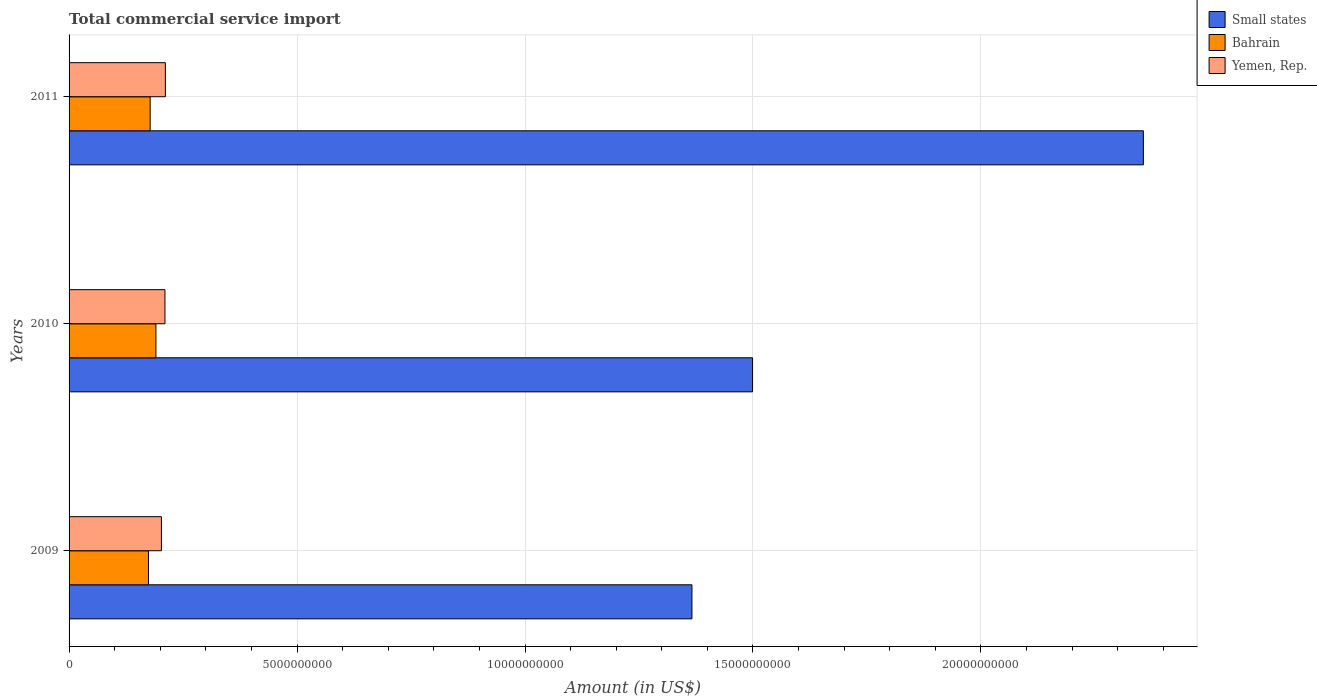How many groups of bars are there?
Provide a succinct answer. 3. How many bars are there on the 3rd tick from the bottom?
Make the answer very short. 3. What is the label of the 1st group of bars from the top?
Provide a short and direct response. 2011. In how many cases, is the number of bars for a given year not equal to the number of legend labels?
Keep it short and to the point. 0. What is the total commercial service import in Bahrain in 2011?
Ensure brevity in your answer.  1.78e+09. Across all years, what is the maximum total commercial service import in Bahrain?
Offer a terse response. 1.91e+09. Across all years, what is the minimum total commercial service import in Bahrain?
Keep it short and to the point. 1.74e+09. In which year was the total commercial service import in Small states minimum?
Your response must be concise. 2009. What is the total total commercial service import in Bahrain in the graph?
Keep it short and to the point. 5.42e+09. What is the difference between the total commercial service import in Bahrain in 2010 and that in 2011?
Offer a very short reply. 1.27e+08. What is the difference between the total commercial service import in Bahrain in 2009 and the total commercial service import in Small states in 2011?
Ensure brevity in your answer.  -2.18e+1. What is the average total commercial service import in Bahrain per year?
Offer a terse response. 1.81e+09. In the year 2010, what is the difference between the total commercial service import in Bahrain and total commercial service import in Small states?
Give a very brief answer. -1.31e+1. In how many years, is the total commercial service import in Bahrain greater than 3000000000 US$?
Ensure brevity in your answer.  0. What is the ratio of the total commercial service import in Bahrain in 2009 to that in 2011?
Offer a terse response. 0.98. Is the total commercial service import in Bahrain in 2009 less than that in 2011?
Your answer should be compact. Yes. What is the difference between the highest and the second highest total commercial service import in Yemen, Rep.?
Ensure brevity in your answer.  9.16e+06. What is the difference between the highest and the lowest total commercial service import in Bahrain?
Make the answer very short. 1.64e+08. Is the sum of the total commercial service import in Yemen, Rep. in 2009 and 2010 greater than the maximum total commercial service import in Bahrain across all years?
Make the answer very short. Yes. What does the 1st bar from the top in 2009 represents?
Offer a terse response. Yemen, Rep. What does the 1st bar from the bottom in 2011 represents?
Offer a terse response. Small states. Is it the case that in every year, the sum of the total commercial service import in Yemen, Rep. and total commercial service import in Bahrain is greater than the total commercial service import in Small states?
Your answer should be very brief. No. How many bars are there?
Your answer should be compact. 9. How many years are there in the graph?
Make the answer very short. 3. Are the values on the major ticks of X-axis written in scientific E-notation?
Ensure brevity in your answer.  No. Does the graph contain any zero values?
Offer a very short reply. No. Does the graph contain grids?
Keep it short and to the point. Yes. How many legend labels are there?
Make the answer very short. 3. How are the legend labels stacked?
Your answer should be very brief. Vertical. What is the title of the graph?
Offer a very short reply. Total commercial service import. Does "Cameroon" appear as one of the legend labels in the graph?
Ensure brevity in your answer.  No. What is the label or title of the X-axis?
Keep it short and to the point. Amount (in US$). What is the label or title of the Y-axis?
Give a very brief answer. Years. What is the Amount (in US$) of Small states in 2009?
Provide a succinct answer. 1.37e+1. What is the Amount (in US$) of Bahrain in 2009?
Ensure brevity in your answer.  1.74e+09. What is the Amount (in US$) in Yemen, Rep. in 2009?
Make the answer very short. 2.03e+09. What is the Amount (in US$) of Small states in 2010?
Ensure brevity in your answer.  1.50e+1. What is the Amount (in US$) of Bahrain in 2010?
Your answer should be compact. 1.91e+09. What is the Amount (in US$) in Yemen, Rep. in 2010?
Provide a succinct answer. 2.10e+09. What is the Amount (in US$) in Small states in 2011?
Provide a succinct answer. 2.36e+1. What is the Amount (in US$) in Bahrain in 2011?
Offer a very short reply. 1.78e+09. What is the Amount (in US$) of Yemen, Rep. in 2011?
Provide a succinct answer. 2.11e+09. Across all years, what is the maximum Amount (in US$) in Small states?
Ensure brevity in your answer.  2.36e+1. Across all years, what is the maximum Amount (in US$) of Bahrain?
Offer a terse response. 1.91e+09. Across all years, what is the maximum Amount (in US$) in Yemen, Rep.?
Your response must be concise. 2.11e+09. Across all years, what is the minimum Amount (in US$) in Small states?
Provide a succinct answer. 1.37e+1. Across all years, what is the minimum Amount (in US$) in Bahrain?
Your answer should be compact. 1.74e+09. Across all years, what is the minimum Amount (in US$) of Yemen, Rep.?
Your answer should be compact. 2.03e+09. What is the total Amount (in US$) of Small states in the graph?
Your answer should be very brief. 5.22e+1. What is the total Amount (in US$) of Bahrain in the graph?
Your answer should be compact. 5.42e+09. What is the total Amount (in US$) in Yemen, Rep. in the graph?
Make the answer very short. 6.24e+09. What is the difference between the Amount (in US$) in Small states in 2009 and that in 2010?
Provide a short and direct response. -1.33e+09. What is the difference between the Amount (in US$) of Bahrain in 2009 and that in 2010?
Give a very brief answer. -1.64e+08. What is the difference between the Amount (in US$) of Yemen, Rep. in 2009 and that in 2010?
Give a very brief answer. -7.75e+07. What is the difference between the Amount (in US$) of Small states in 2009 and that in 2011?
Keep it short and to the point. -9.90e+09. What is the difference between the Amount (in US$) of Bahrain in 2009 and that in 2011?
Your answer should be very brief. -3.75e+07. What is the difference between the Amount (in US$) in Yemen, Rep. in 2009 and that in 2011?
Ensure brevity in your answer.  -8.66e+07. What is the difference between the Amount (in US$) of Small states in 2010 and that in 2011?
Provide a short and direct response. -8.57e+09. What is the difference between the Amount (in US$) in Bahrain in 2010 and that in 2011?
Your answer should be compact. 1.27e+08. What is the difference between the Amount (in US$) in Yemen, Rep. in 2010 and that in 2011?
Your answer should be compact. -9.16e+06. What is the difference between the Amount (in US$) in Small states in 2009 and the Amount (in US$) in Bahrain in 2010?
Keep it short and to the point. 1.18e+1. What is the difference between the Amount (in US$) in Small states in 2009 and the Amount (in US$) in Yemen, Rep. in 2010?
Offer a very short reply. 1.16e+1. What is the difference between the Amount (in US$) in Bahrain in 2009 and the Amount (in US$) in Yemen, Rep. in 2010?
Give a very brief answer. -3.62e+08. What is the difference between the Amount (in US$) in Small states in 2009 and the Amount (in US$) in Bahrain in 2011?
Your answer should be very brief. 1.19e+1. What is the difference between the Amount (in US$) of Small states in 2009 and the Amount (in US$) of Yemen, Rep. in 2011?
Offer a terse response. 1.15e+1. What is the difference between the Amount (in US$) of Bahrain in 2009 and the Amount (in US$) of Yemen, Rep. in 2011?
Your response must be concise. -3.71e+08. What is the difference between the Amount (in US$) of Small states in 2010 and the Amount (in US$) of Bahrain in 2011?
Give a very brief answer. 1.32e+1. What is the difference between the Amount (in US$) in Small states in 2010 and the Amount (in US$) in Yemen, Rep. in 2011?
Give a very brief answer. 1.29e+1. What is the difference between the Amount (in US$) of Bahrain in 2010 and the Amount (in US$) of Yemen, Rep. in 2011?
Offer a terse response. -2.07e+08. What is the average Amount (in US$) of Small states per year?
Your response must be concise. 1.74e+1. What is the average Amount (in US$) of Bahrain per year?
Offer a very short reply. 1.81e+09. What is the average Amount (in US$) in Yemen, Rep. per year?
Make the answer very short. 2.08e+09. In the year 2009, what is the difference between the Amount (in US$) in Small states and Amount (in US$) in Bahrain?
Provide a short and direct response. 1.19e+1. In the year 2009, what is the difference between the Amount (in US$) in Small states and Amount (in US$) in Yemen, Rep.?
Offer a very short reply. 1.16e+1. In the year 2009, what is the difference between the Amount (in US$) of Bahrain and Amount (in US$) of Yemen, Rep.?
Offer a terse response. -2.84e+08. In the year 2010, what is the difference between the Amount (in US$) of Small states and Amount (in US$) of Bahrain?
Keep it short and to the point. 1.31e+1. In the year 2010, what is the difference between the Amount (in US$) in Small states and Amount (in US$) in Yemen, Rep.?
Keep it short and to the point. 1.29e+1. In the year 2010, what is the difference between the Amount (in US$) in Bahrain and Amount (in US$) in Yemen, Rep.?
Keep it short and to the point. -1.98e+08. In the year 2011, what is the difference between the Amount (in US$) in Small states and Amount (in US$) in Bahrain?
Keep it short and to the point. 2.18e+1. In the year 2011, what is the difference between the Amount (in US$) in Small states and Amount (in US$) in Yemen, Rep.?
Your answer should be very brief. 2.15e+1. In the year 2011, what is the difference between the Amount (in US$) of Bahrain and Amount (in US$) of Yemen, Rep.?
Ensure brevity in your answer.  -3.34e+08. What is the ratio of the Amount (in US$) in Small states in 2009 to that in 2010?
Give a very brief answer. 0.91. What is the ratio of the Amount (in US$) of Bahrain in 2009 to that in 2010?
Make the answer very short. 0.91. What is the ratio of the Amount (in US$) in Yemen, Rep. in 2009 to that in 2010?
Provide a short and direct response. 0.96. What is the ratio of the Amount (in US$) in Small states in 2009 to that in 2011?
Offer a terse response. 0.58. What is the ratio of the Amount (in US$) in Bahrain in 2009 to that in 2011?
Your answer should be very brief. 0.98. What is the ratio of the Amount (in US$) of Small states in 2010 to that in 2011?
Your response must be concise. 0.64. What is the ratio of the Amount (in US$) of Bahrain in 2010 to that in 2011?
Make the answer very short. 1.07. What is the difference between the highest and the second highest Amount (in US$) in Small states?
Offer a very short reply. 8.57e+09. What is the difference between the highest and the second highest Amount (in US$) in Bahrain?
Your response must be concise. 1.27e+08. What is the difference between the highest and the second highest Amount (in US$) in Yemen, Rep.?
Provide a succinct answer. 9.16e+06. What is the difference between the highest and the lowest Amount (in US$) of Small states?
Keep it short and to the point. 9.90e+09. What is the difference between the highest and the lowest Amount (in US$) of Bahrain?
Offer a terse response. 1.64e+08. What is the difference between the highest and the lowest Amount (in US$) in Yemen, Rep.?
Your response must be concise. 8.66e+07. 